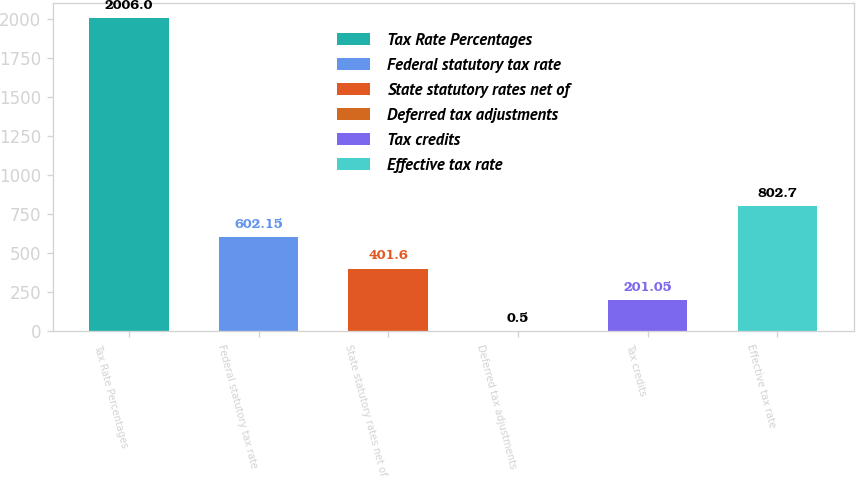<chart> <loc_0><loc_0><loc_500><loc_500><bar_chart><fcel>Tax Rate Percentages<fcel>Federal statutory tax rate<fcel>State statutory rates net of<fcel>Deferred tax adjustments<fcel>Tax credits<fcel>Effective tax rate<nl><fcel>2006<fcel>602.15<fcel>401.6<fcel>0.5<fcel>201.05<fcel>802.7<nl></chart> 